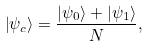<formula> <loc_0><loc_0><loc_500><loc_500>\left | \psi _ { c } \right \rangle = \frac { \left | \psi _ { 0 } \right \rangle + \left | \psi _ { 1 } \right \rangle } { N } ,</formula> 